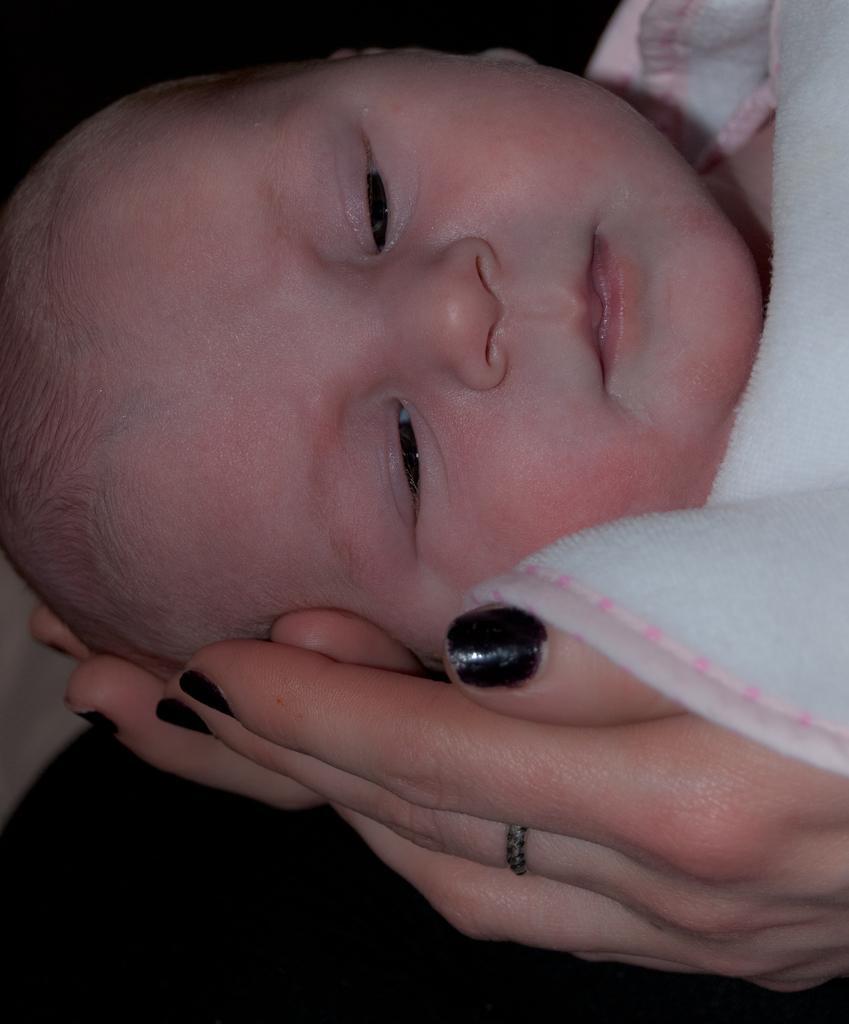Describe this image in one or two sentences. In this image we can see a woman holding a baby with her hands. 